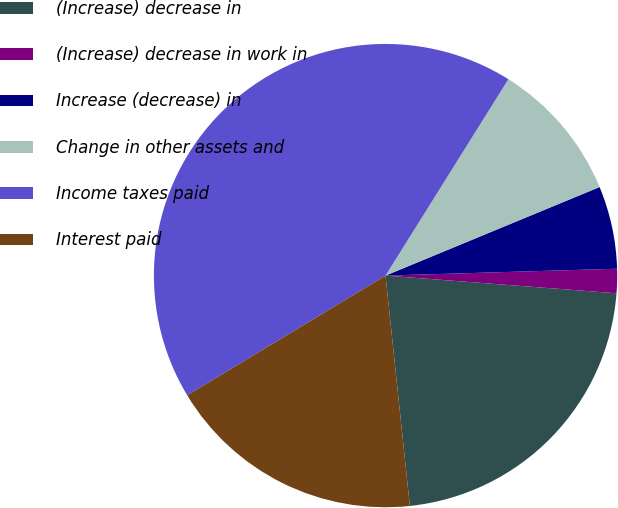<chart> <loc_0><loc_0><loc_500><loc_500><pie_chart><fcel>(Increase) decrease in<fcel>(Increase) decrease in work in<fcel>Increase (decrease) in<fcel>Change in other assets and<fcel>Income taxes paid<fcel>Interest paid<nl><fcel>22.11%<fcel>1.69%<fcel>5.77%<fcel>9.86%<fcel>42.54%<fcel>18.03%<nl></chart> 